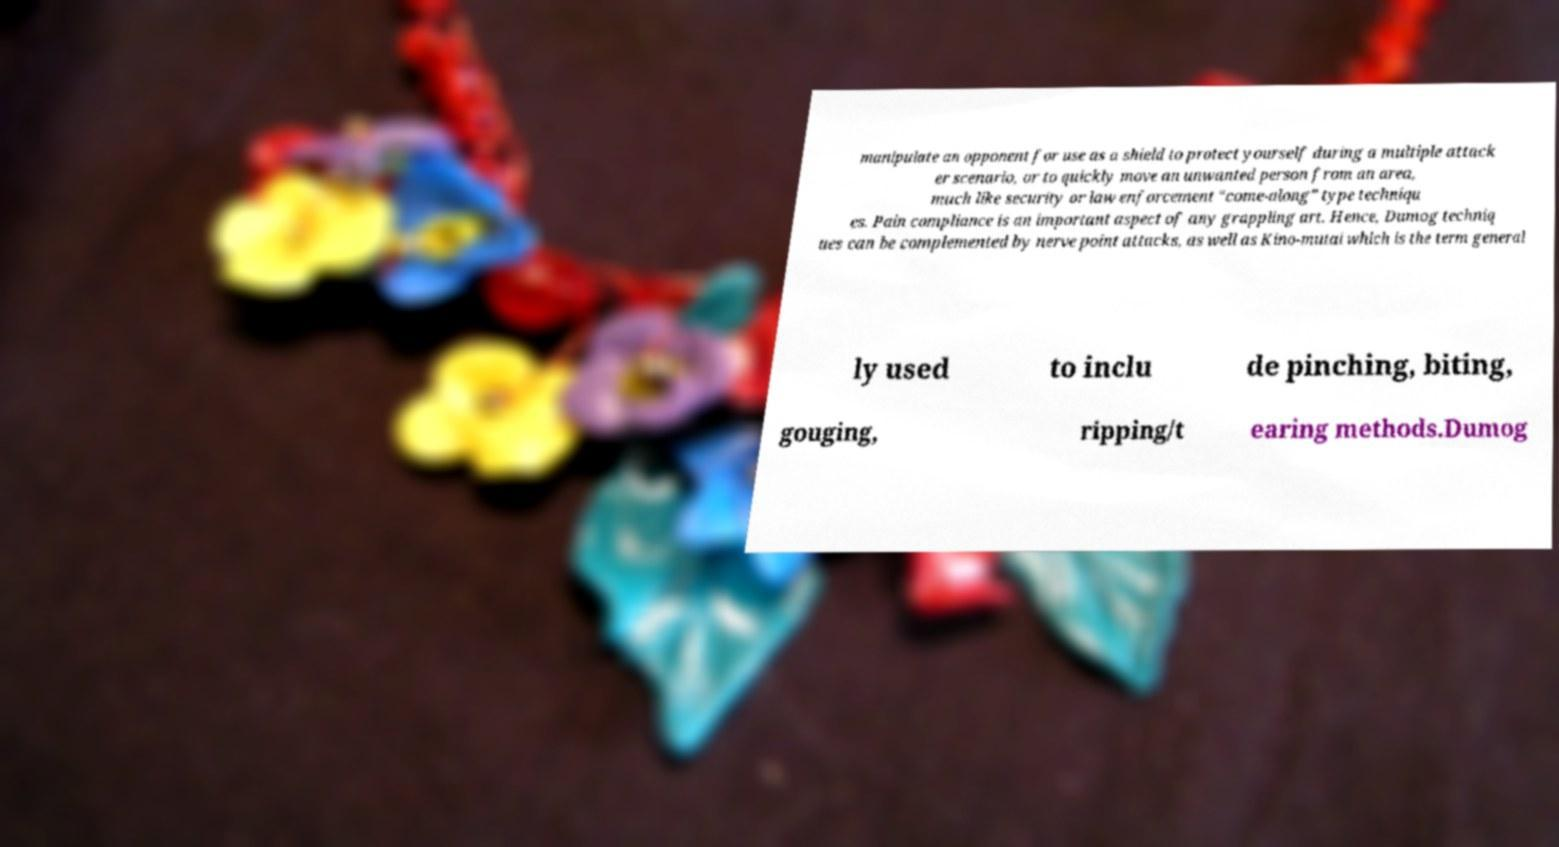What messages or text are displayed in this image? I need them in a readable, typed format. manipulate an opponent for use as a shield to protect yourself during a multiple attack er scenario, or to quickly move an unwanted person from an area, much like security or law enforcement “come-along” type techniqu es. Pain compliance is an important aspect of any grappling art. Hence, Dumog techniq ues can be complemented by nerve point attacks, as well as Kino-mutai which is the term general ly used to inclu de pinching, biting, gouging, ripping/t earing methods.Dumog 